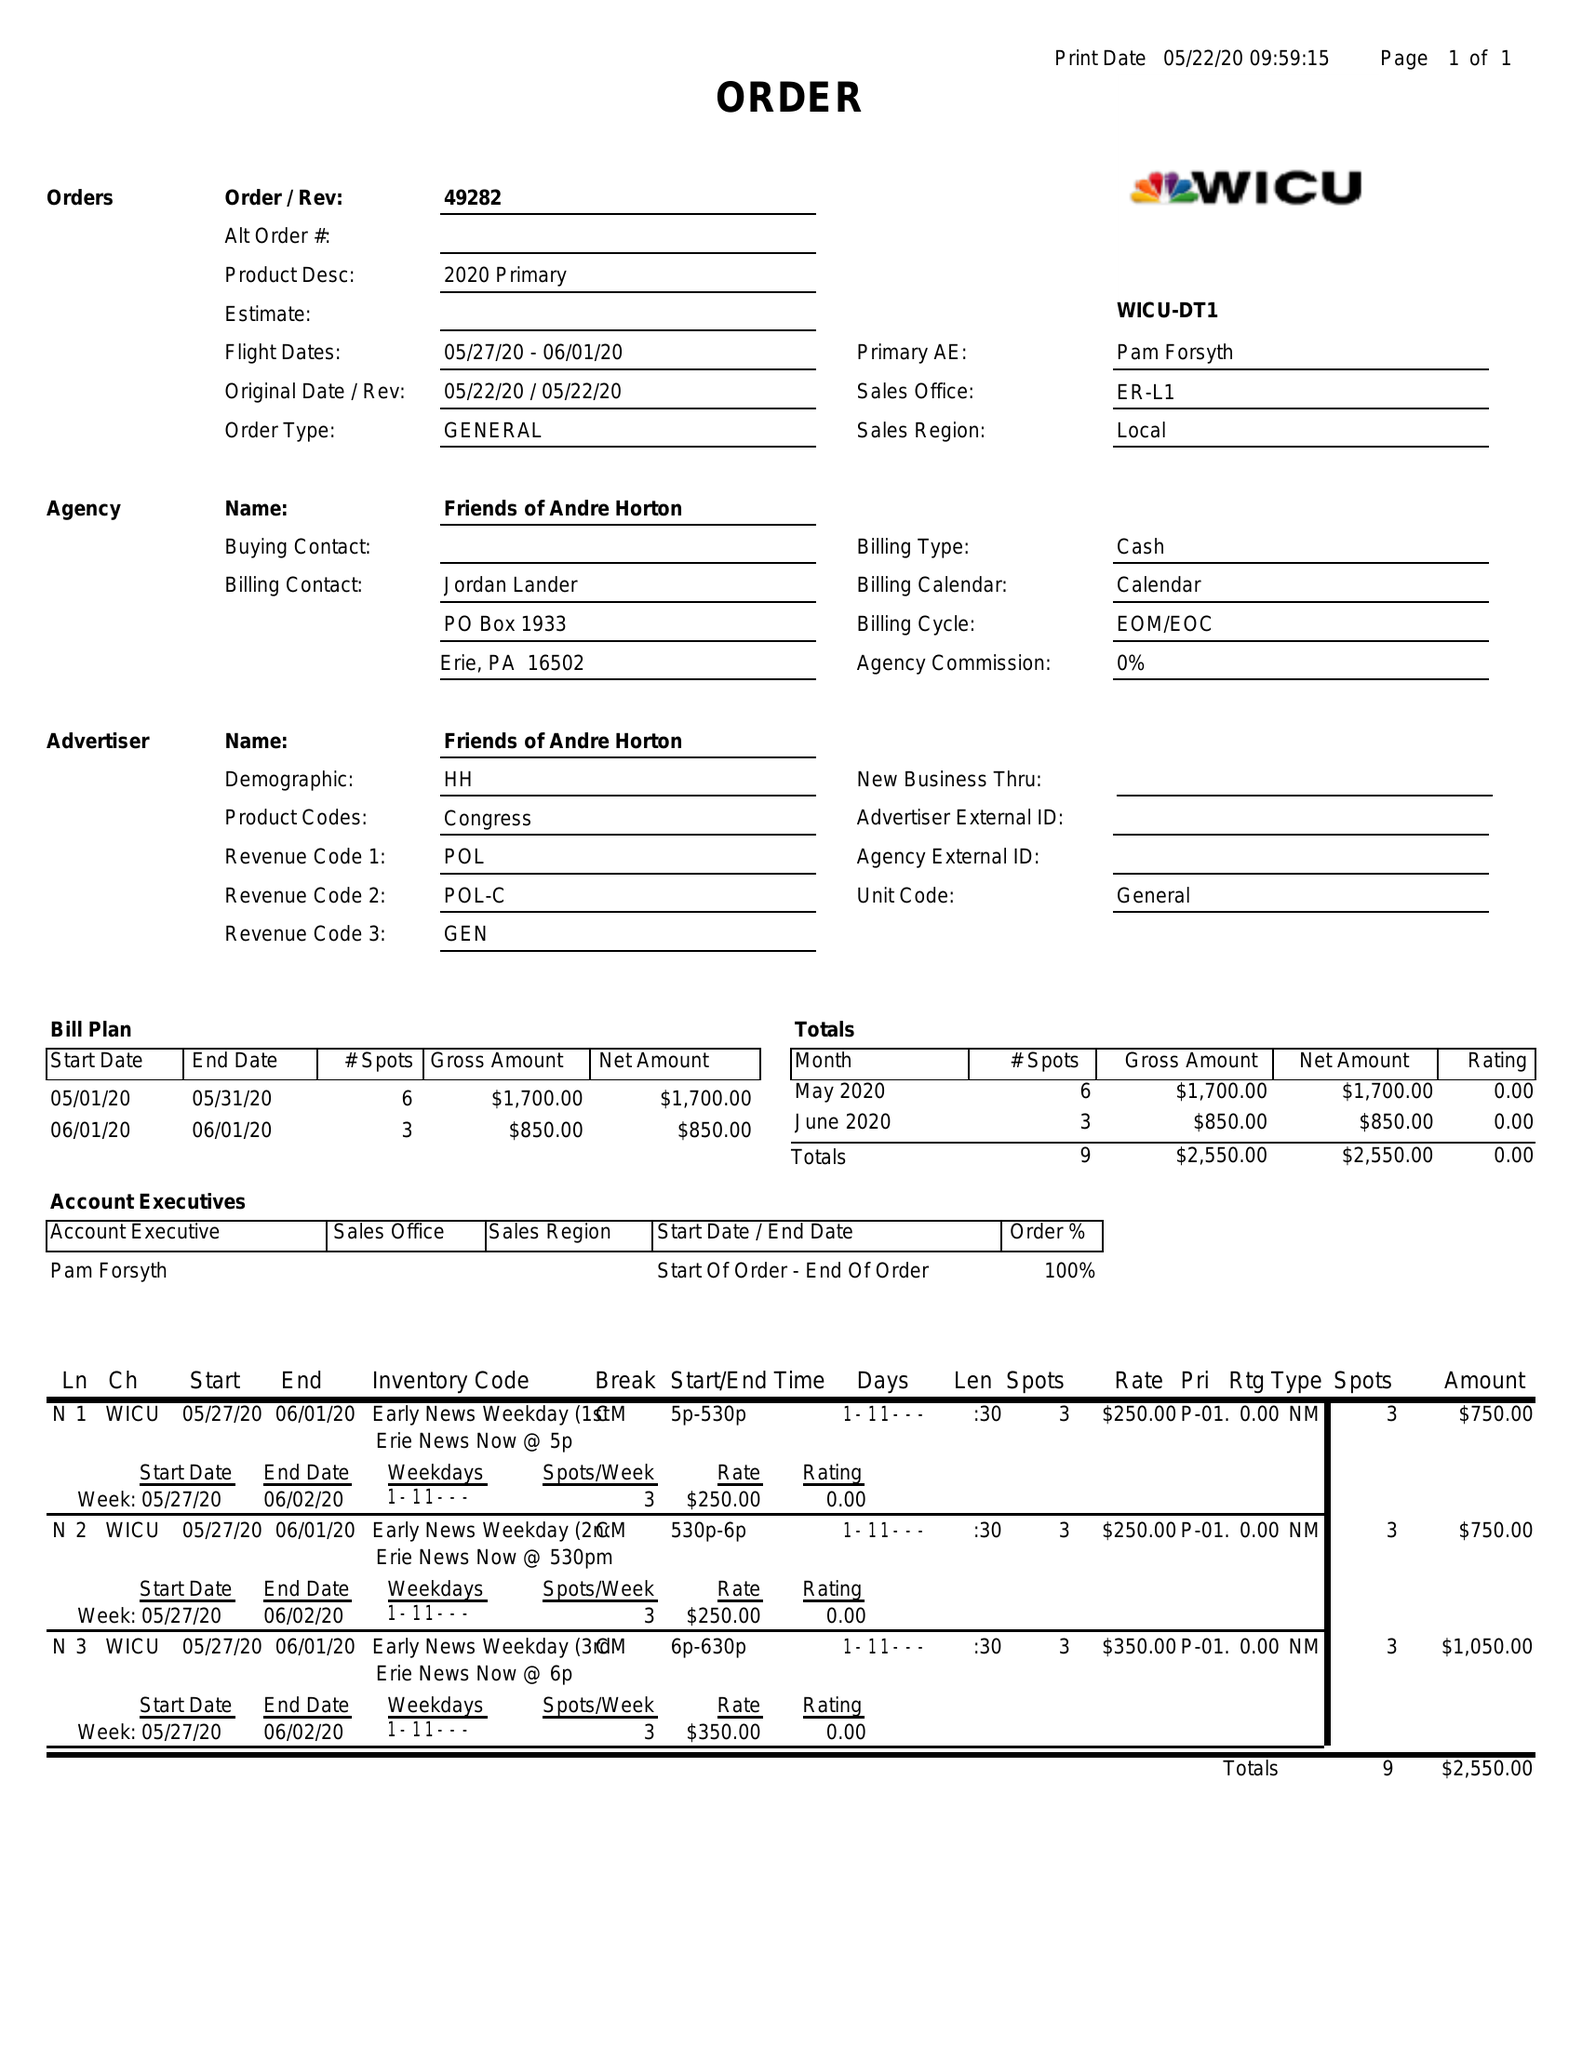What is the value for the flight_from?
Answer the question using a single word or phrase. 05/27/20 